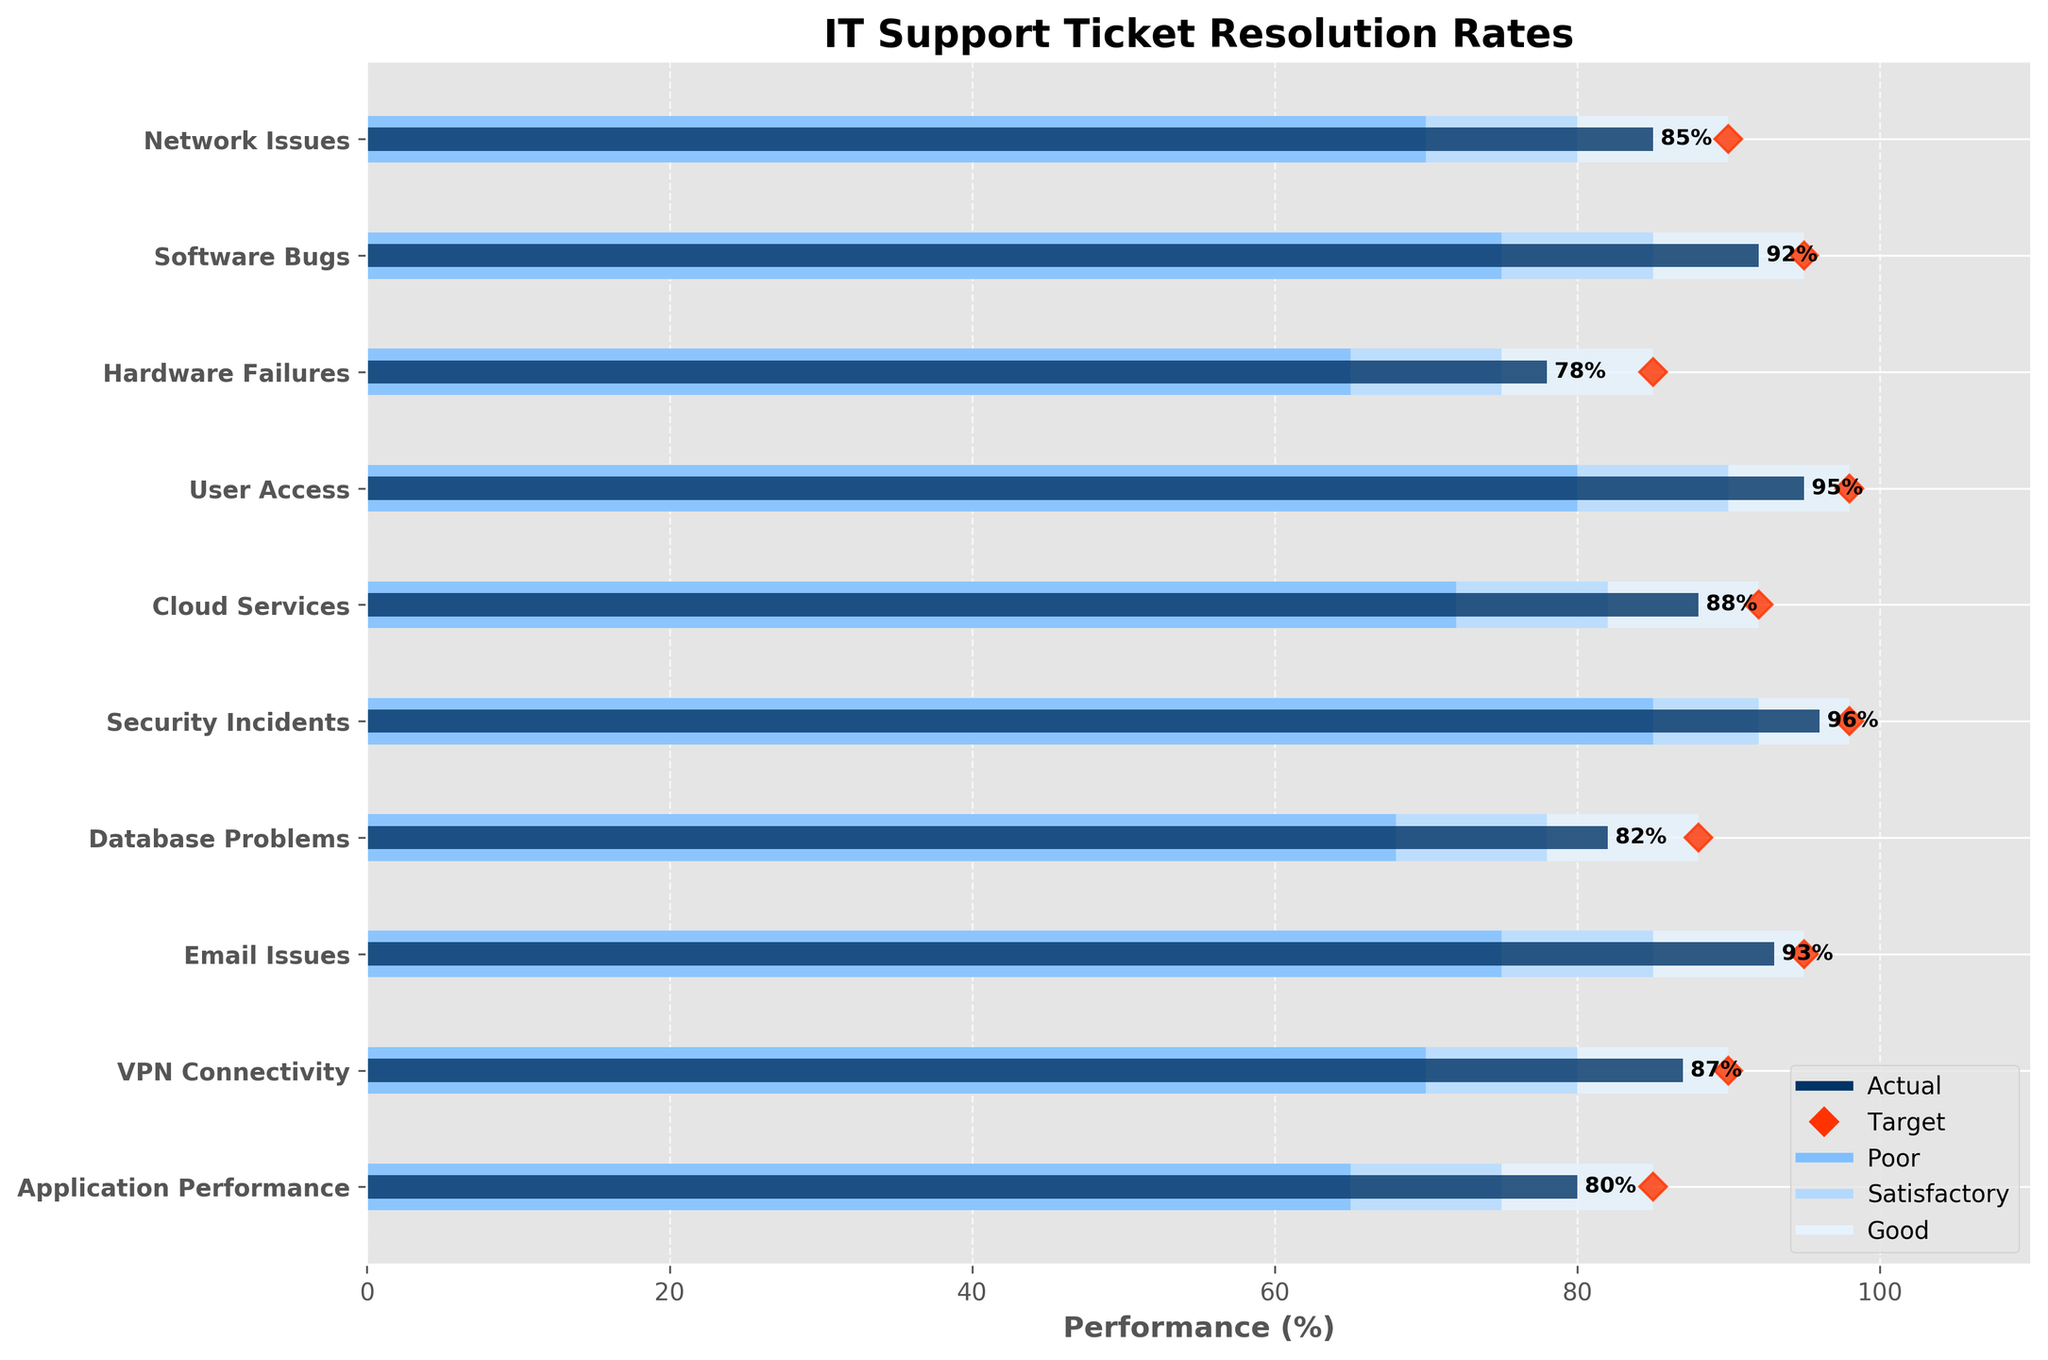What's the title of the chart? The title is located at the top of the chart. It provides a quick summary of the data being presented.
Answer: IT Support Ticket Resolution Rates What color represents 'Good' performance? According to the legend, 'Good' performance is marked by the background color used for the bars denoting this level.
Answer: Light blue What is the highest actual performance percentage? To find this, you need to look at the bar heights for 'Actual' and identify the tallest one. The 'Actual' bars are dark blue.
Answer: 96% How many categories met or exceeded their target? To answer this, compare the actual performance (dark blue bars) with the target markers (red diamonds) for each category. Count how many have actual performance equal to or higher than the target.
Answer: 4 Which category is farthest from meeting its target? Compare the actual performance (dark blue bars) to their respective targets (red diamonds) and identify the category with the largest negative gap.
Answer: Hardware Failures What's the average target percentage across all categories? Add up all the target percentages and divide by the number of categories. Specifically, the targets are (90 + 95 + 85 + 98 + 92 + 98 + 88 + 95 + 90 + 85).
Answer: 91.6 What specific target percentage is marked with a diamond shape? The diamond shape targets are the values marked with red diamonds.
Answer: 85%-98% Which two categories have the smallest difference between their actual and target performance? Calculate the difference between actual and target performance for each category and find the two smallest differences. The categories with the bars closest to their diamonds would be these two.
Answer: Network Issues and VPN Connectivity If 'Satisfactory' is between the range of the lower bound of 'Good' and the upper bound of 'Poor', what categories fall into this 'Satisfactory' range? Satisfactory levels are visualized by the middle colored section in the bullet bar. Compare the actual performance of each category to the Satisfactory section's range.
Answer: Network Issues, Software Bugs, Email Issues, VPN Connectivity Which incidents fall into different performance ranges based on their respective actual performance? To answer, match the actual performance (dark blue bars) with the colored performance ranges (Good, Satisfactory, Poor). List examples from different ranges.
Answer: Network Issues - Satisfactory, Security Incidents - Good, Hardware Failures - Poor 